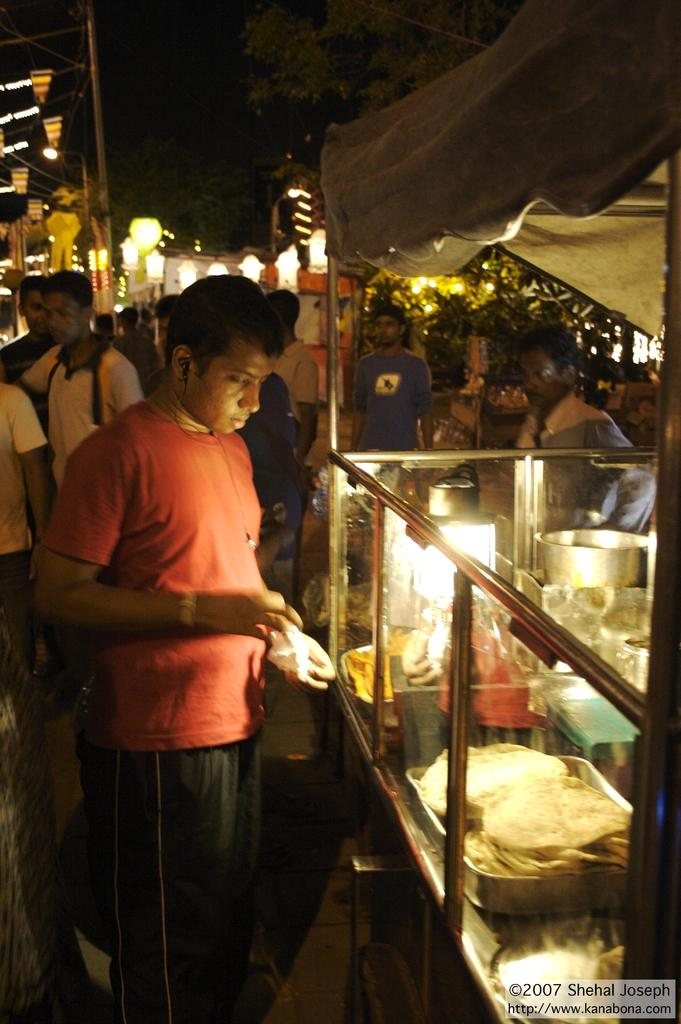How many persons can be seen in the image? There are persons in the image, but the exact number is not specified. What type of establishment is depicted in the image? There is a stall in the image. What type of items are visible in the image? There is food, a tray, and a bowl in the image. What can be seen in the background of the image? There are lights, poles, and trees in the background of the image. What language is being spoken by the persons in the image? The facts provided do not mention any spoken language, so it cannot be determined from the image. How many boats are visible in the image? There are no boats present in the image. 